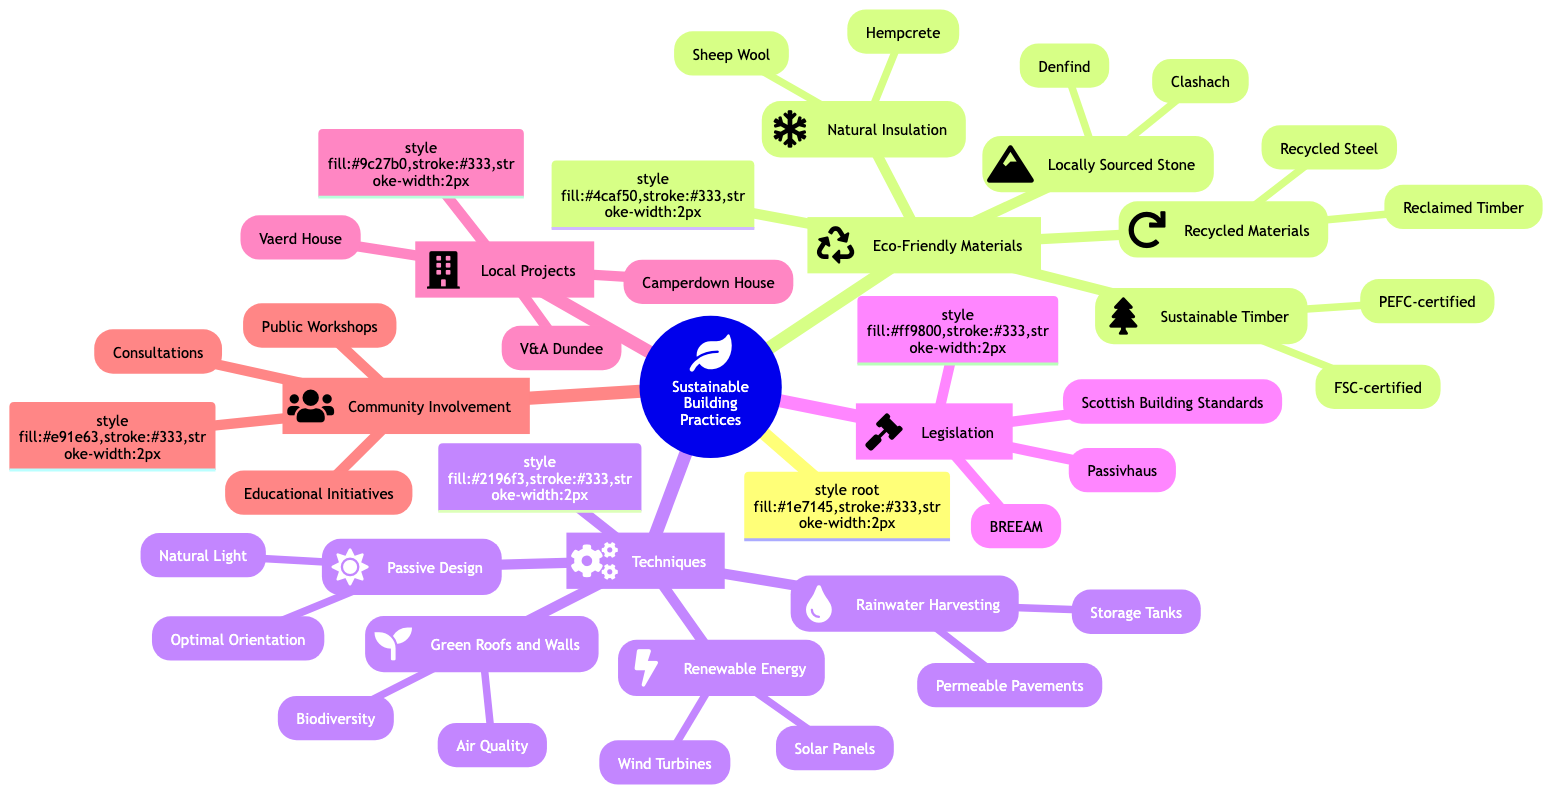What are the two types of eco-friendly materials listed? The diagram categorizes eco-friendly materials into two main types: "Eco-Friendly Materials" and "Techniques." Under "Eco-Friendly Materials," the main categories include "Locally Sourced Stone" and "Recycled Materials" among others.
Answer: Locally Sourced Stone, Recycled Materials How many local example projects are mentioned? The diagram specifically lists two local example projects under the "Local Example Projects" branch: "Vaerd House" and "Camperdown House." This indicates there are only two listed projects.
Answer: 2 What benefits are associated with Green Roofs and Walls? The benefits listed for "Green Roofs and Walls" in the diagram include "Increased Biodiversity" and "Improved Air Quality." These advantages directly relate to the environmental impacts of such structures.
Answer: Increased Biodiversity, Improved Air Quality Which two certifications are mentioned for sustainably harvested timber? The diagram shows that sustainably harvested timber can be certified as "FSC-certified" and "PEFC-certified." These certifications ensure that the materials are sourced responsibly.
Answer: FSC-certified, PEFC-certified Name one technique used in passive design and an example of its application in Dundee. The diagram outlines one technique under "Passive Design" as "Optimal Building Orientation," with an example application being "V&A Dundee (waterfront cooling)," which showcases how design can maximize environmental benefits.
Answer: Optimal Building Orientation, V&A Dundee (waterfront cooling) What legislation governs building standards in Scotland? The diagram lists "Scottish Building Standards" as the governing legislation for building standards in Scotland, which outlines the requirements for energy efficiency and sustainability in construction projects.
Answer: Scottish Building Standards How many sources of renewable energy integration are listed? The diagram lists two primary sources of renewable energy integration: "Solar Panels" and "Wind Turbines." Each represents a significant method of harnessing natural energy for sustainable practices.
Answer: 2 What educational initiatives are highlighted in the community involvement section? The diagram states that the "University of Dundee's School of Architecture" and "Dundee Urban Design Framework" are prominent educational initiatives aimed at promoting sustainability and architectural education within the community.
Answer: University of Dundee's School of Architecture, Dundee Urban Design Framework 